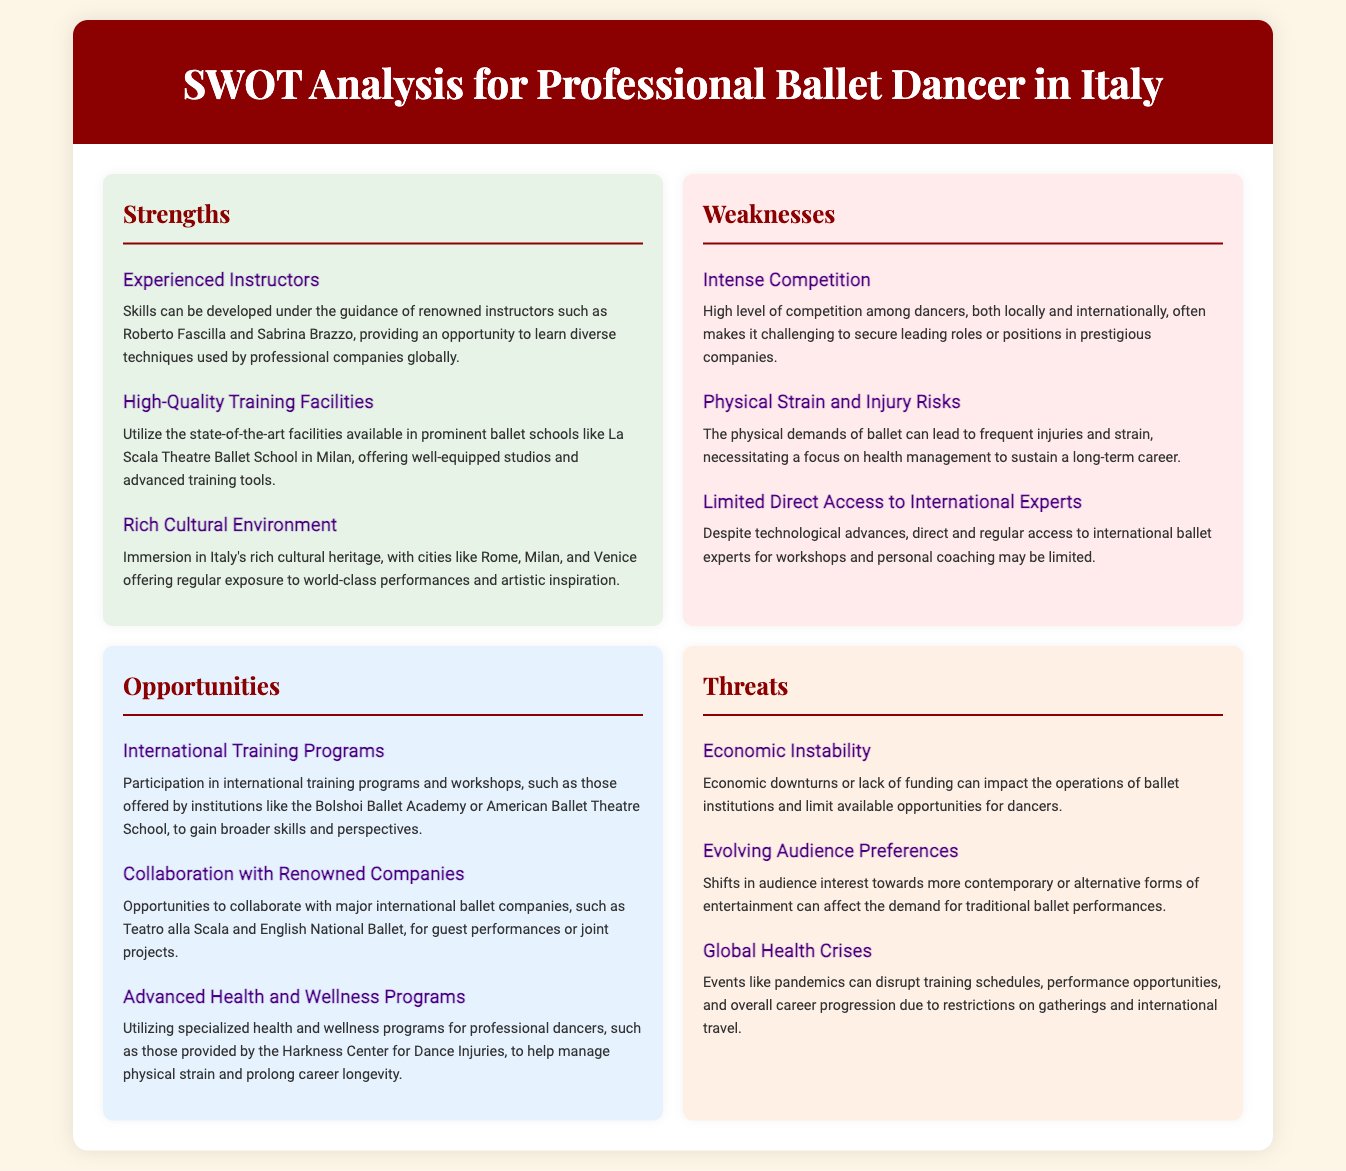what are the names of two renowned instructors mentioned? The document mentions two experienced instructors: Roberto Fascilla and Sabrina Brazzo, who guide skill development.
Answer: Roberto Fascilla, Sabrina Brazzo what is a strength related to training facilities? The document states that there are high-quality training facilities at prominent ballet schools like La Scala Theatre Ballet School, which offers well-equipped studios.
Answer: High-Quality Training Facilities name a weakness regarding competition. The document highlights that there is intense competition among dancers, making it challenging to secure roles in prestigious companies.
Answer: Intense Competition which institution is mentioned for international training programs? The document lists the Bolshoi Ballet Academy as one of the institutions offering international training programs and workshops.
Answer: Bolshoi Ballet Academy what is a potential threat to ballet dancers discussed in the document? The document identifies global health crises, such as pandemics, as a threat that can disrupt training and performance opportunities.
Answer: Global Health Crises how can dancers manage their physical strain according to the opportunities section? The document suggests that dancers can utilize advanced health and wellness programs for managing physical strain, like those offered by the Harkness Center for Dance Injuries.
Answer: Advanced Health and Wellness Programs what does the rich cultural environment provide? The document notes that the rich cultural environment in Italy offers immersion in cultural heritage and regular exposure to world-class performances.
Answer: Cultural Heritage which city is specifically mentioned for its state-of-the-art training facilities? The document mentions Milan, referring to the La Scala Theatre Ballet School that offers state-of-the-art facilities.
Answer: Milan what kind of collaboration opportunities are suggested in the document? The document discusses collaboration with renowned companies like Teatro alla Scala and English National Ballet for performances or joint projects.
Answer: Collaboration with Renowned Companies 